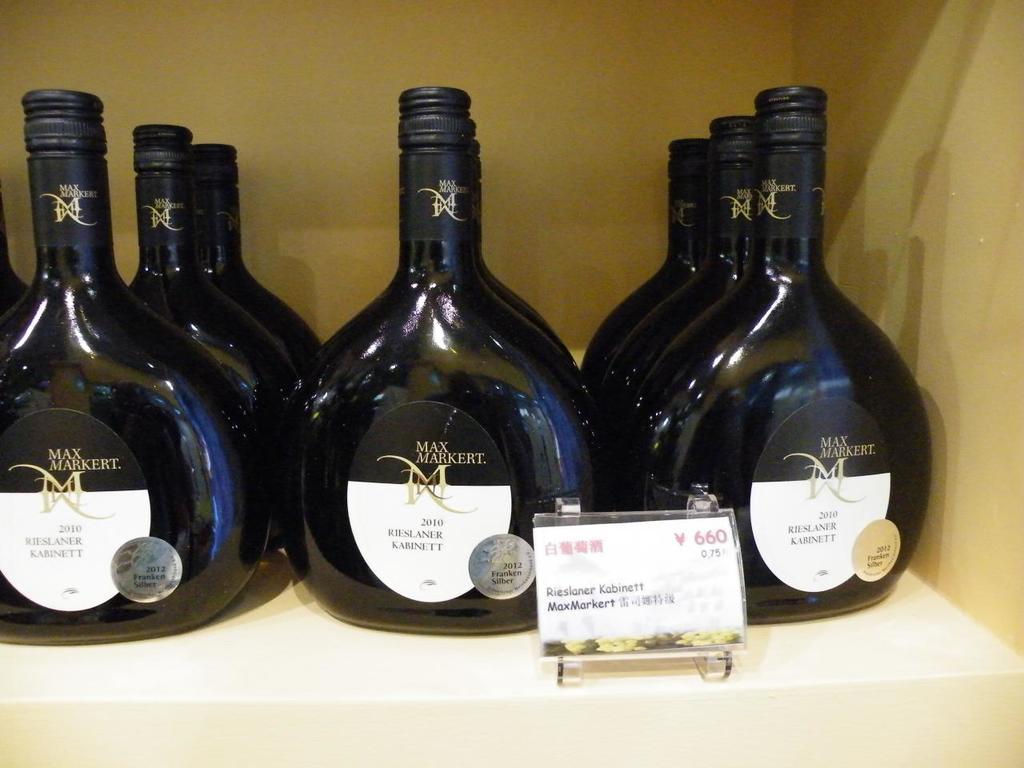What is the brand of wine ?
Give a very brief answer. Max markert. Is this a brandy?
Offer a terse response. No. 